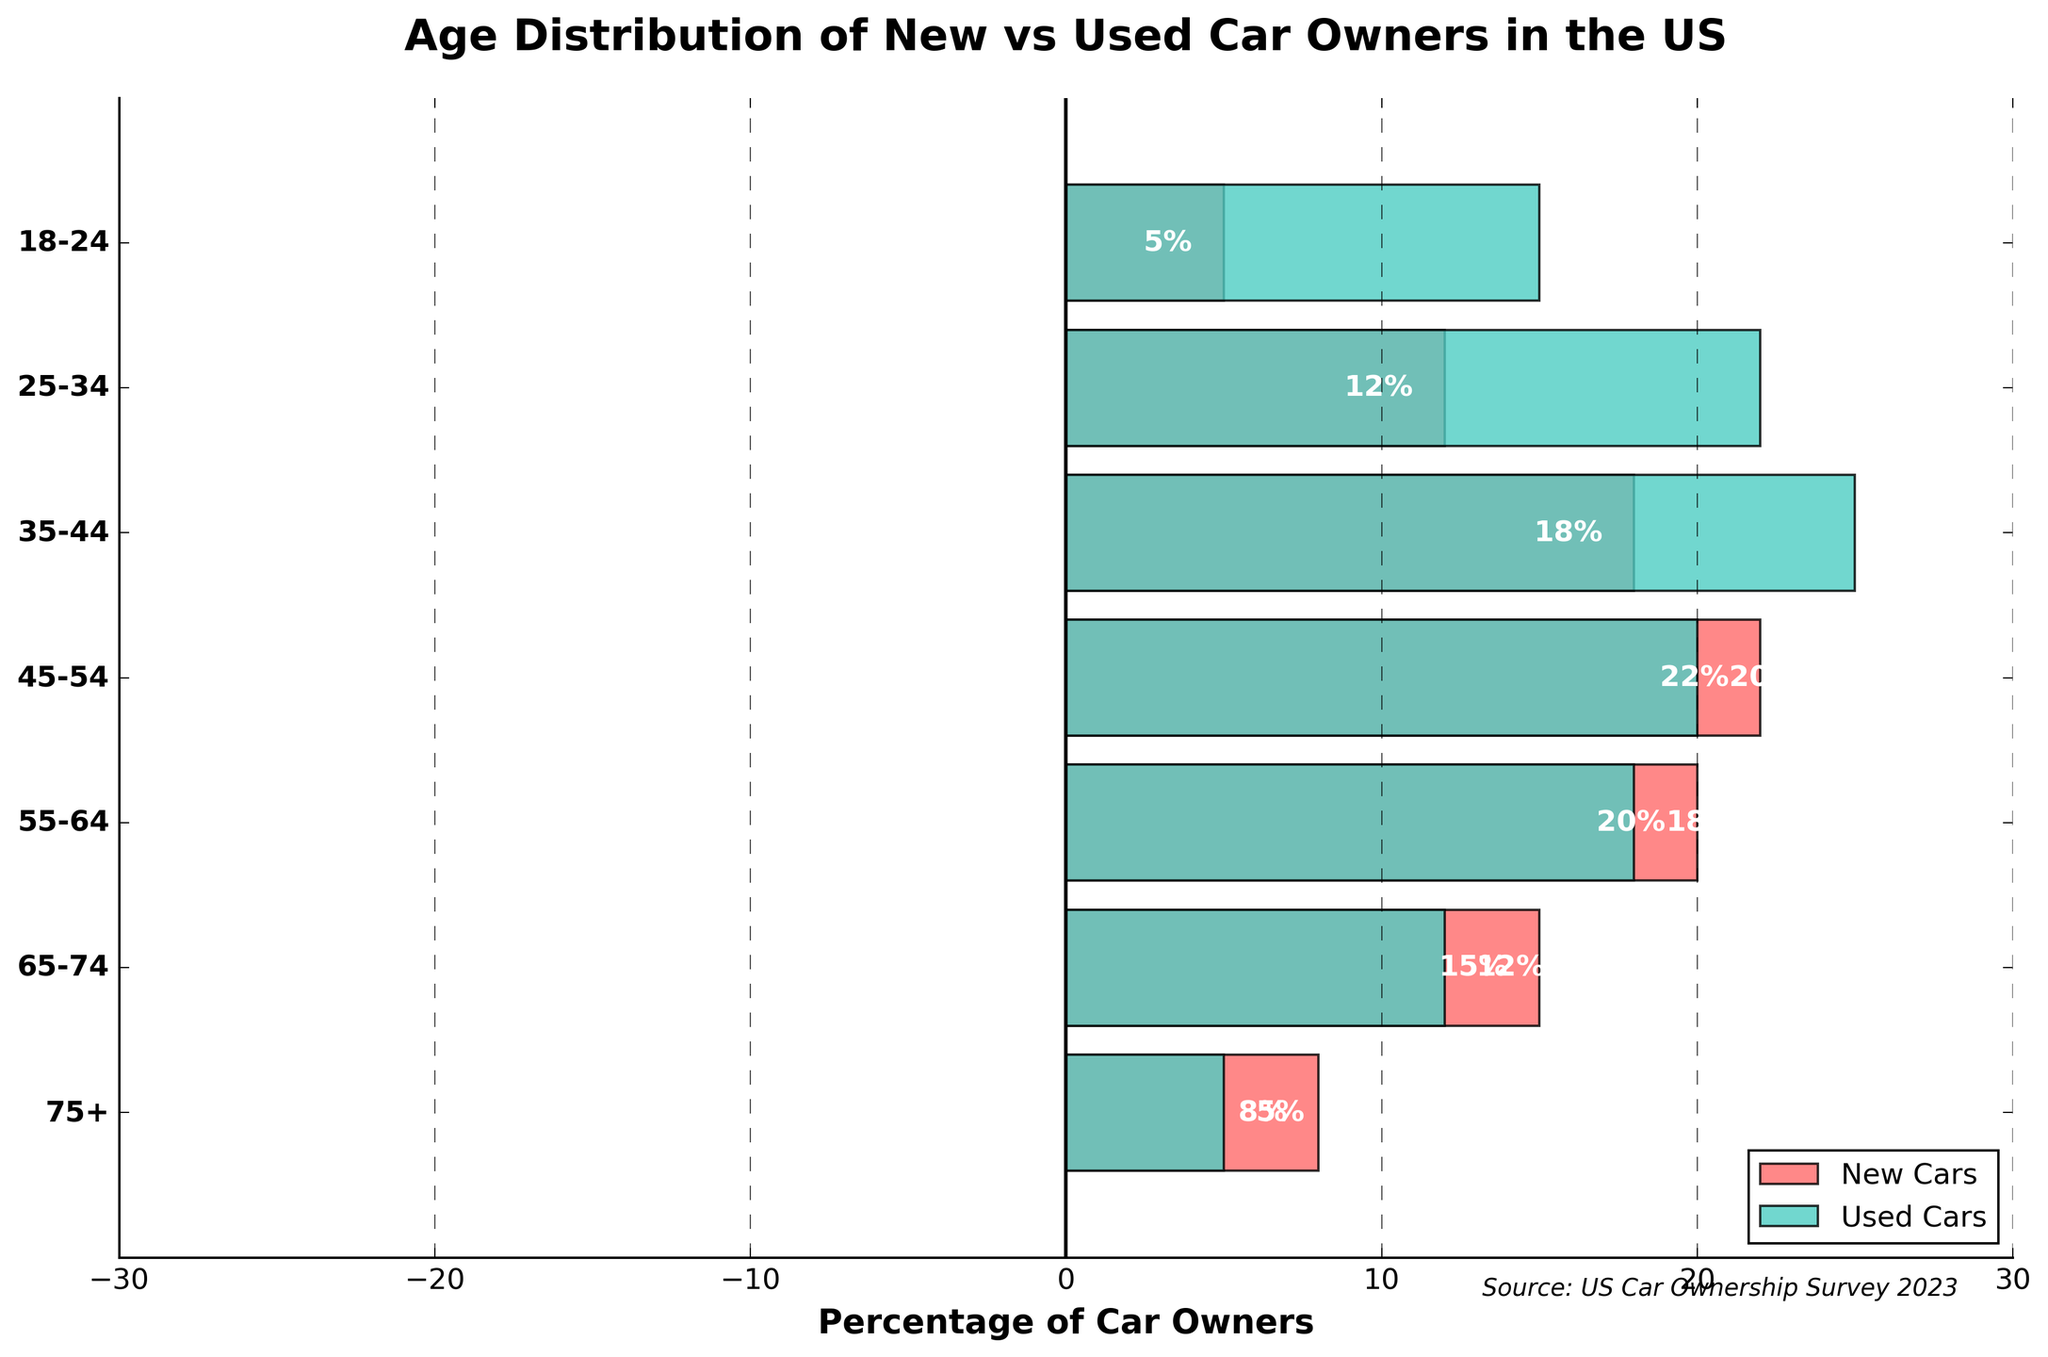What age group has the highest percentage of used car owners? The highest percentage of used car owners is indicated by the longest green bar. In the plot, the 35-44 age group has the longest green bar, with 25%.
Answer: 35-44 Which age group has the highest percentage of new car owners? The highest percentage of new car owners is indicated by the longest red bar (on the negative side). The age group 45-54 has the longest red bar with 22%.
Answer: 45-54 How does the percentage of new car owners compare between the 25-34 and 55-64 age groups? For the 25-34 age group, the percentage of new car owners is 12%, and for the 55-64 age group, it is 20%. The 55-64 age group has a higher percentage of new car owners by 8% (20%-12%).
Answer: 55-64 > 25-34 by 8% What is the total percentage of car owners (both new and used) in the 18-24 age group? The 18-24 age group has 5% new car owners and 15% used car owners. Summing these values gives a total of 5% + 15% = 20%.
Answer: 20% What is the average percentage of new car owners across all age groups? Sum the new car percentages (ignoring the negative sign for calculation) and divide by the number of age groups: (5 + 12 + 18 + 22 + 20 + 15 + 8) / 7 = 100 / 7. The average is approximately 14.3%.
Answer: 14.3% Which age groups have more used car owners than new car owners? Compare the lengths of the bars on both sides for each age group. All age groups (18-24, 25-34, 35-44, 45-54, 55-64, 65-74, 75+) have more used car owners than new car owners, as indicated by longer green bars.
Answer: All age groups How does the percentage of used car owners change from the 65-74 age group to the 75+ age group? The percentage of used car owners decreases from 12% in the 65-74 age group to 5% in the 75+ age group, a reduction of 7%.
Answer: Decreases by 7% What is the ratio of used to new car owners in the 35-44 age group? The percentage of used car owners in the 35-44 age group is 25%, and the percentage of new car owners is 18%. The ratio is 25 : 18, which simplifies to approximately 1.39 : 1 when divided by 18.
Answer: 1.39 : 1 